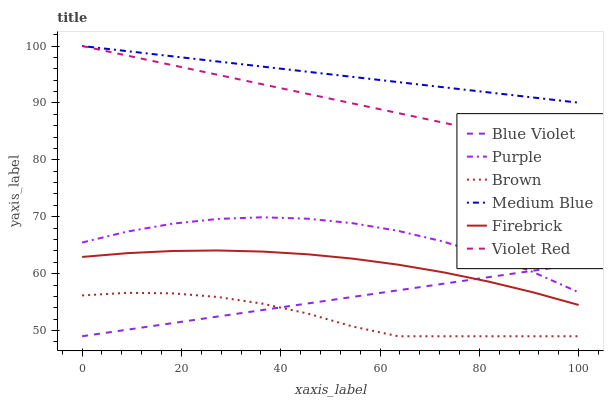Does Violet Red have the minimum area under the curve?
Answer yes or no. No. Does Violet Red have the maximum area under the curve?
Answer yes or no. No. Is Violet Red the smoothest?
Answer yes or no. No. Is Violet Red the roughest?
Answer yes or no. No. Does Violet Red have the lowest value?
Answer yes or no. No. Does Purple have the highest value?
Answer yes or no. No. Is Brown less than Violet Red?
Answer yes or no. Yes. Is Purple greater than Firebrick?
Answer yes or no. Yes. Does Brown intersect Violet Red?
Answer yes or no. No. 